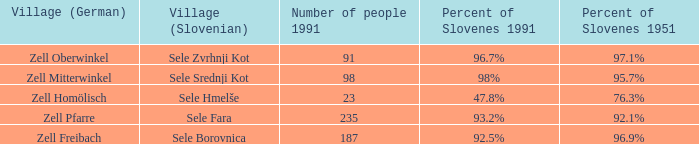Provide with the names of the village (German) that is part of village (Slovenian) with sele srednji kot. Zell Mitterwinkel. 